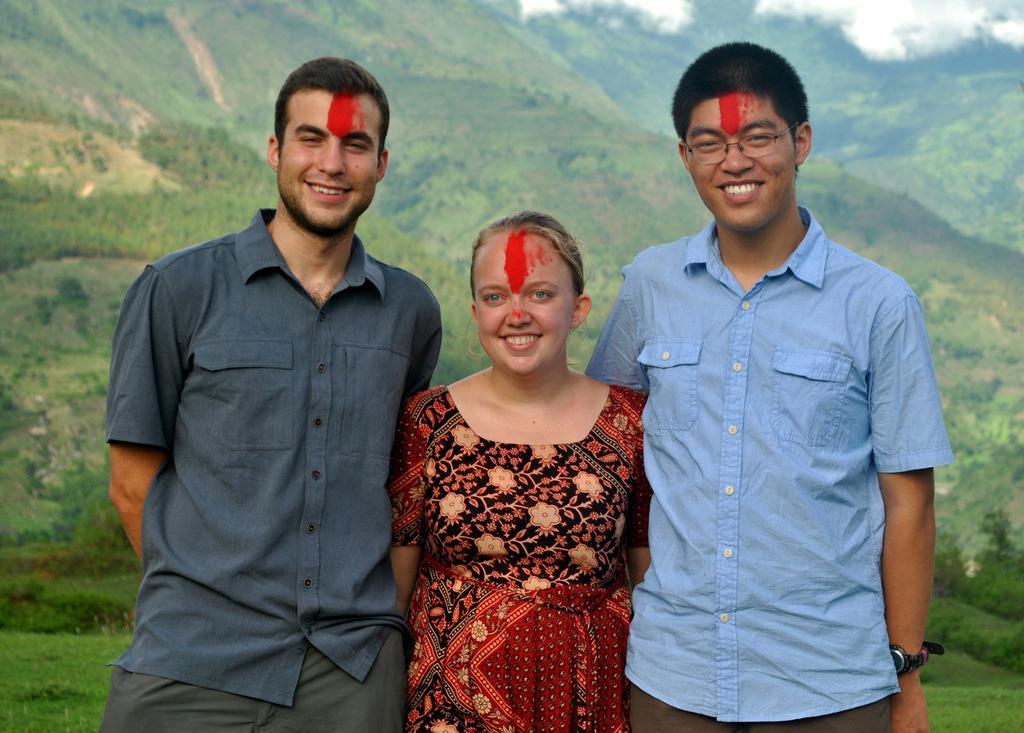In one or two sentences, can you explain what this image depicts? In the front of the image three people are standing and smiling. In the background there are clouds, trees and grass. 